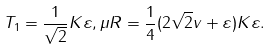Convert formula to latex. <formula><loc_0><loc_0><loc_500><loc_500>T _ { 1 } = \frac { 1 } { \sqrt { 2 } } K \varepsilon , \mu R = \frac { 1 } { 4 } ( 2 \sqrt { 2 } v + \varepsilon ) K \varepsilon .</formula> 